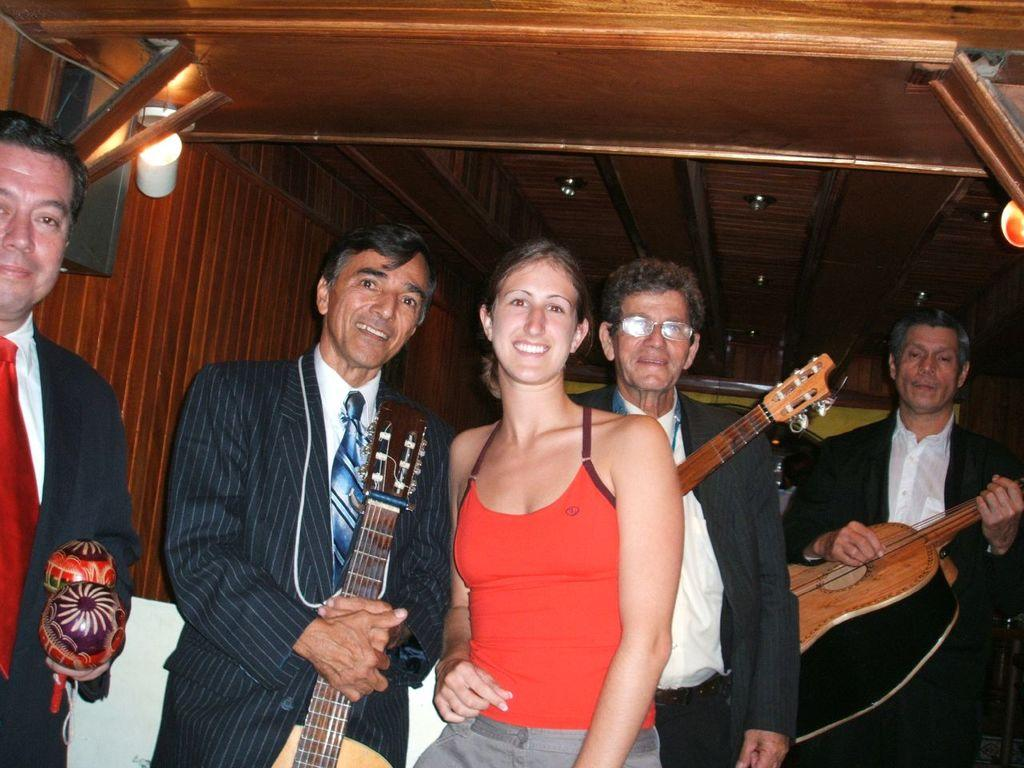What are the persons in the image doing? The persons in the image are giving a pose to a camera. What is the facial expression of the persons in the image? The persons in the image are smiling. What objects are the men holding in their hands? The men are holding guitars in their hands. How many pies can be seen on the table in the image? There is no table or pies present in the image. What type of dime is visible on the floor in the image? There is no dime visible on the floor in the image. 